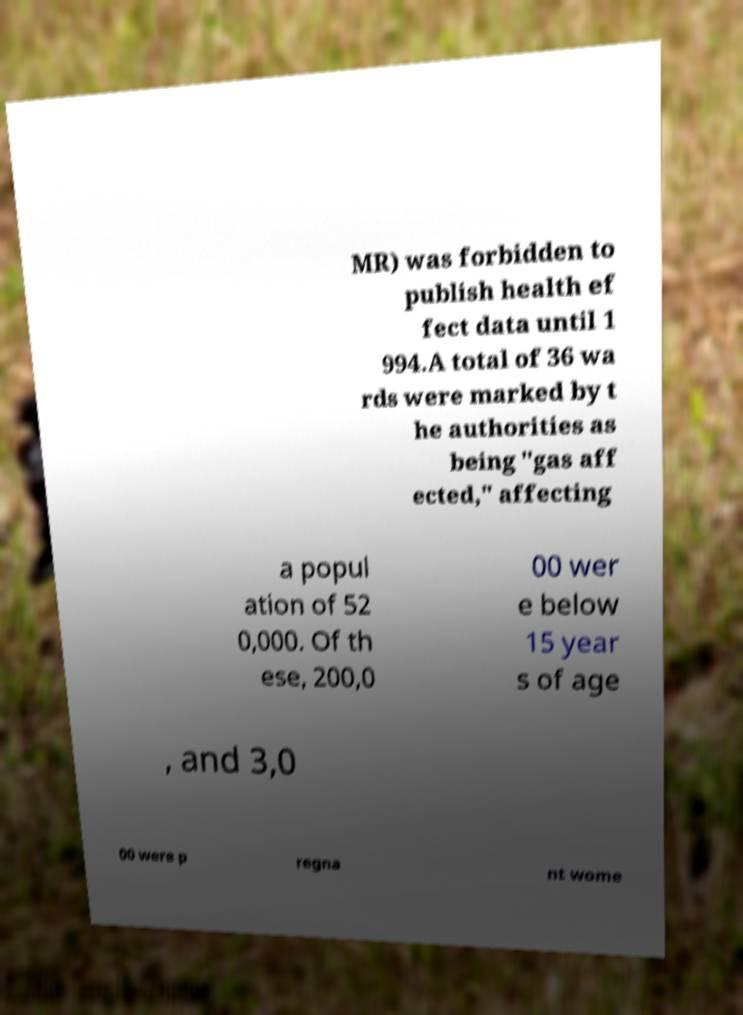Could you extract and type out the text from this image? MR) was forbidden to publish health ef fect data until 1 994.A total of 36 wa rds were marked by t he authorities as being "gas aff ected," affecting a popul ation of 52 0,000. Of th ese, 200,0 00 wer e below 15 year s of age , and 3,0 00 were p regna nt wome 